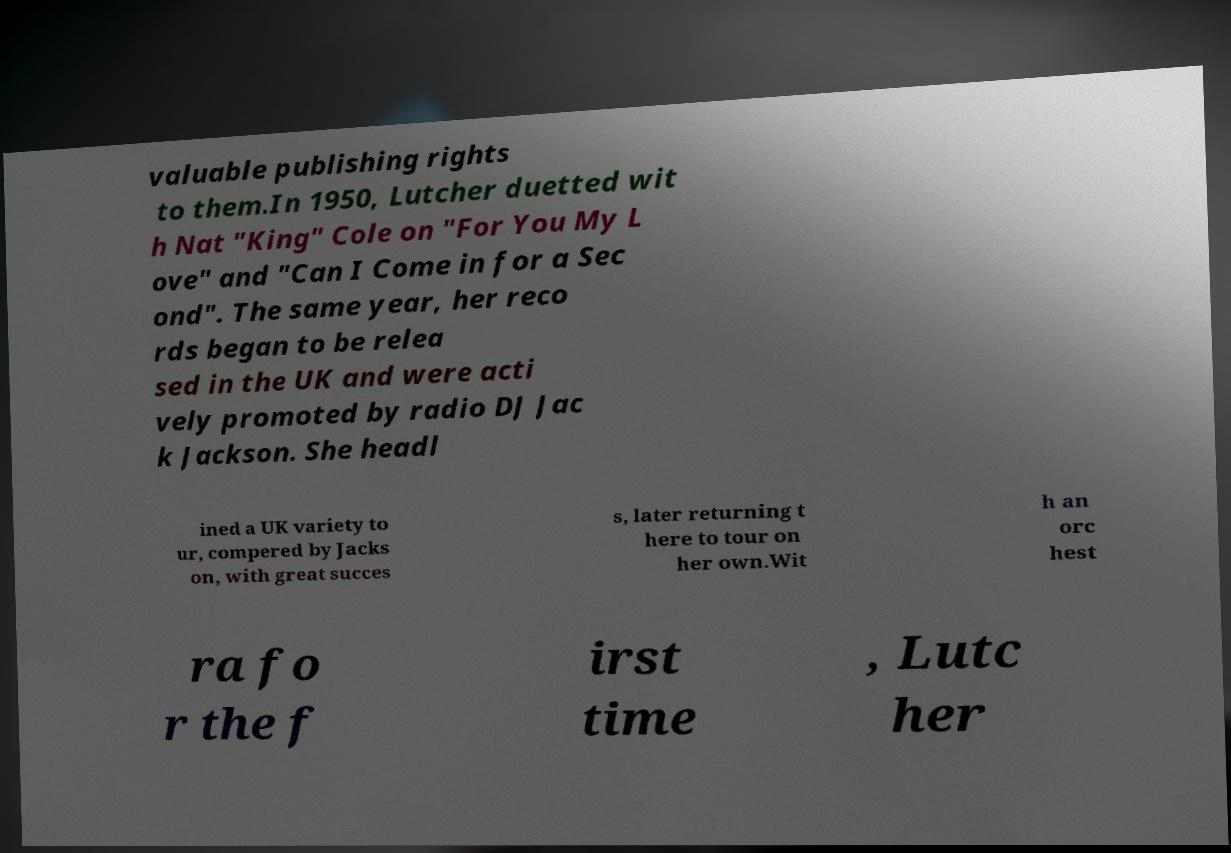Could you assist in decoding the text presented in this image and type it out clearly? valuable publishing rights to them.In 1950, Lutcher duetted wit h Nat "King" Cole on "For You My L ove" and "Can I Come in for a Sec ond". The same year, her reco rds began to be relea sed in the UK and were acti vely promoted by radio DJ Jac k Jackson. She headl ined a UK variety to ur, compered by Jacks on, with great succes s, later returning t here to tour on her own.Wit h an orc hest ra fo r the f irst time , Lutc her 